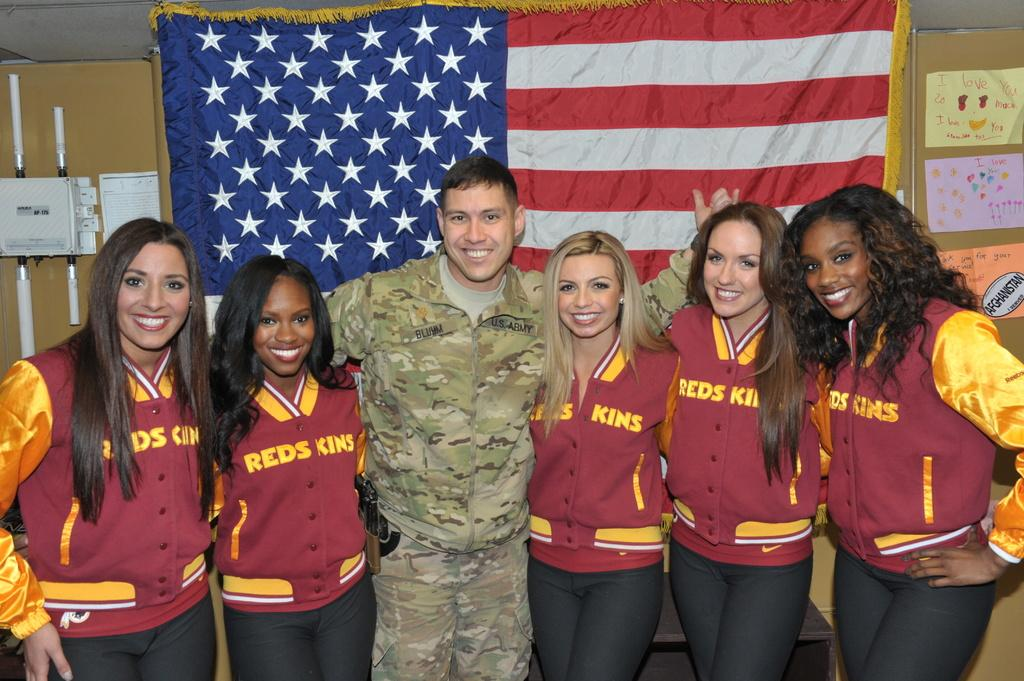Provide a one-sentence caption for the provided image. A group of women wearing the jackets with the word redskins on them standing before a flag with a soldier. 